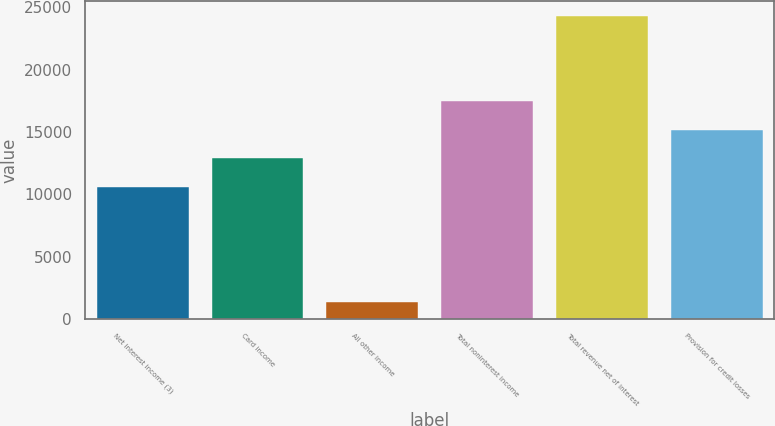<chart> <loc_0><loc_0><loc_500><loc_500><bar_chart><fcel>Net interest income (3)<fcel>Card income<fcel>All other income<fcel>Total noninterest income<fcel>Total revenue net of interest<fcel>Provision for credit losses<nl><fcel>10604<fcel>12892.6<fcel>1377<fcel>17469.8<fcel>24263<fcel>15181.2<nl></chart> 